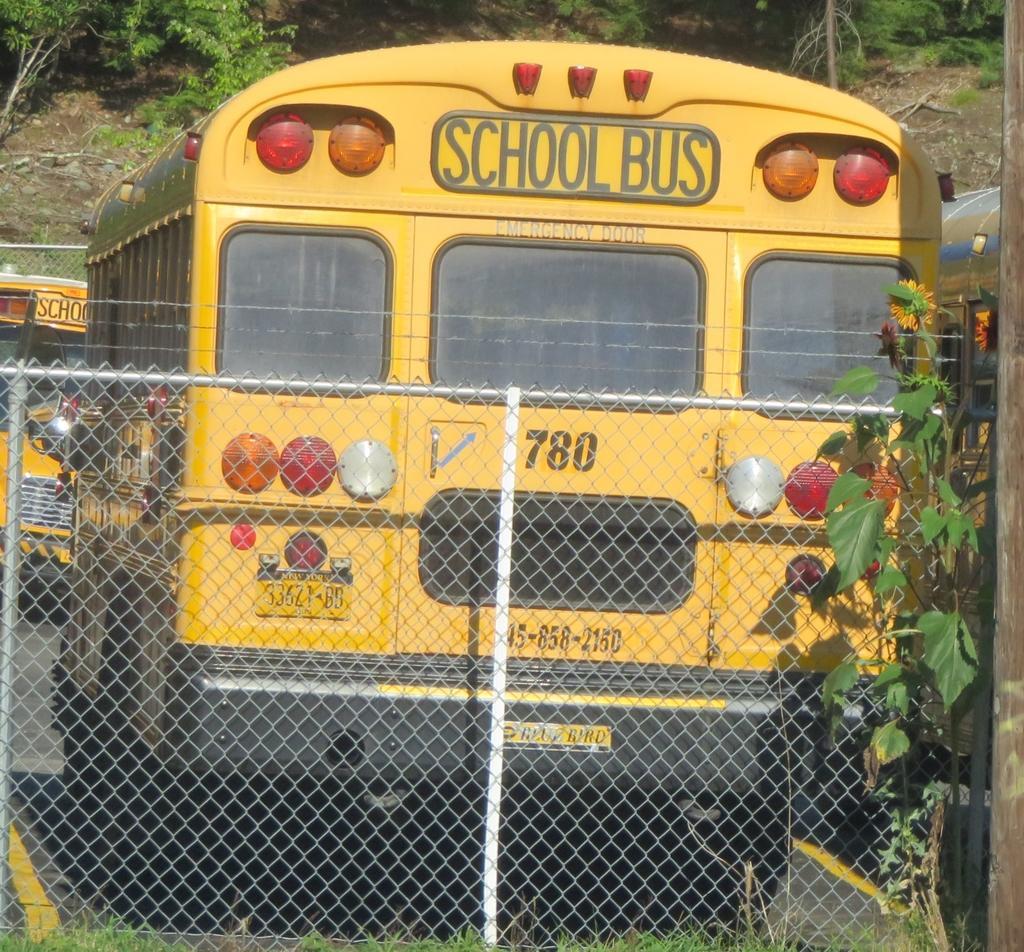Can you describe this image briefly? There are buses with windows, lights and something written on the bus. There is a mesh fencing. On the right side there is a plant. In the background there are trees. 